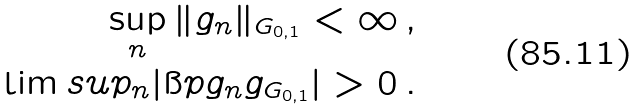<formula> <loc_0><loc_0><loc_500><loc_500>\sup _ { n } \| g _ { n } \| _ { G _ { 0 , 1 } } < \infty \, , \\ \lim s u p _ { n } | \i p { g _ { n } } { g } _ { G _ { 0 , 1 } } | > 0 \, .</formula> 